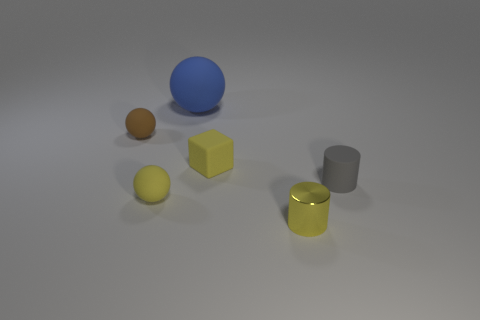Is there anything else that is the same size as the blue rubber object?
Your answer should be compact. No. Is the color of the block the same as the large rubber sphere?
Provide a short and direct response. No. Does the yellow cylinder have the same material as the big blue ball?
Ensure brevity in your answer.  No. How many rubber things are big brown blocks or tiny balls?
Ensure brevity in your answer.  2. There is a tiny rubber thing that is the same color as the block; what is its shape?
Provide a succinct answer. Sphere. There is a tiny sphere that is behind the small gray matte cylinder; does it have the same color as the metallic cylinder?
Provide a succinct answer. No. What shape is the yellow object behind the small thing that is to the right of the small yellow cylinder?
Offer a very short reply. Cube. How many things are tiny matte things that are on the left side of the cube or yellow things right of the blue sphere?
Offer a terse response. 4. What is the shape of the tiny gray thing that is made of the same material as the brown ball?
Your response must be concise. Cylinder. Are there any other things of the same color as the cube?
Offer a terse response. Yes. 